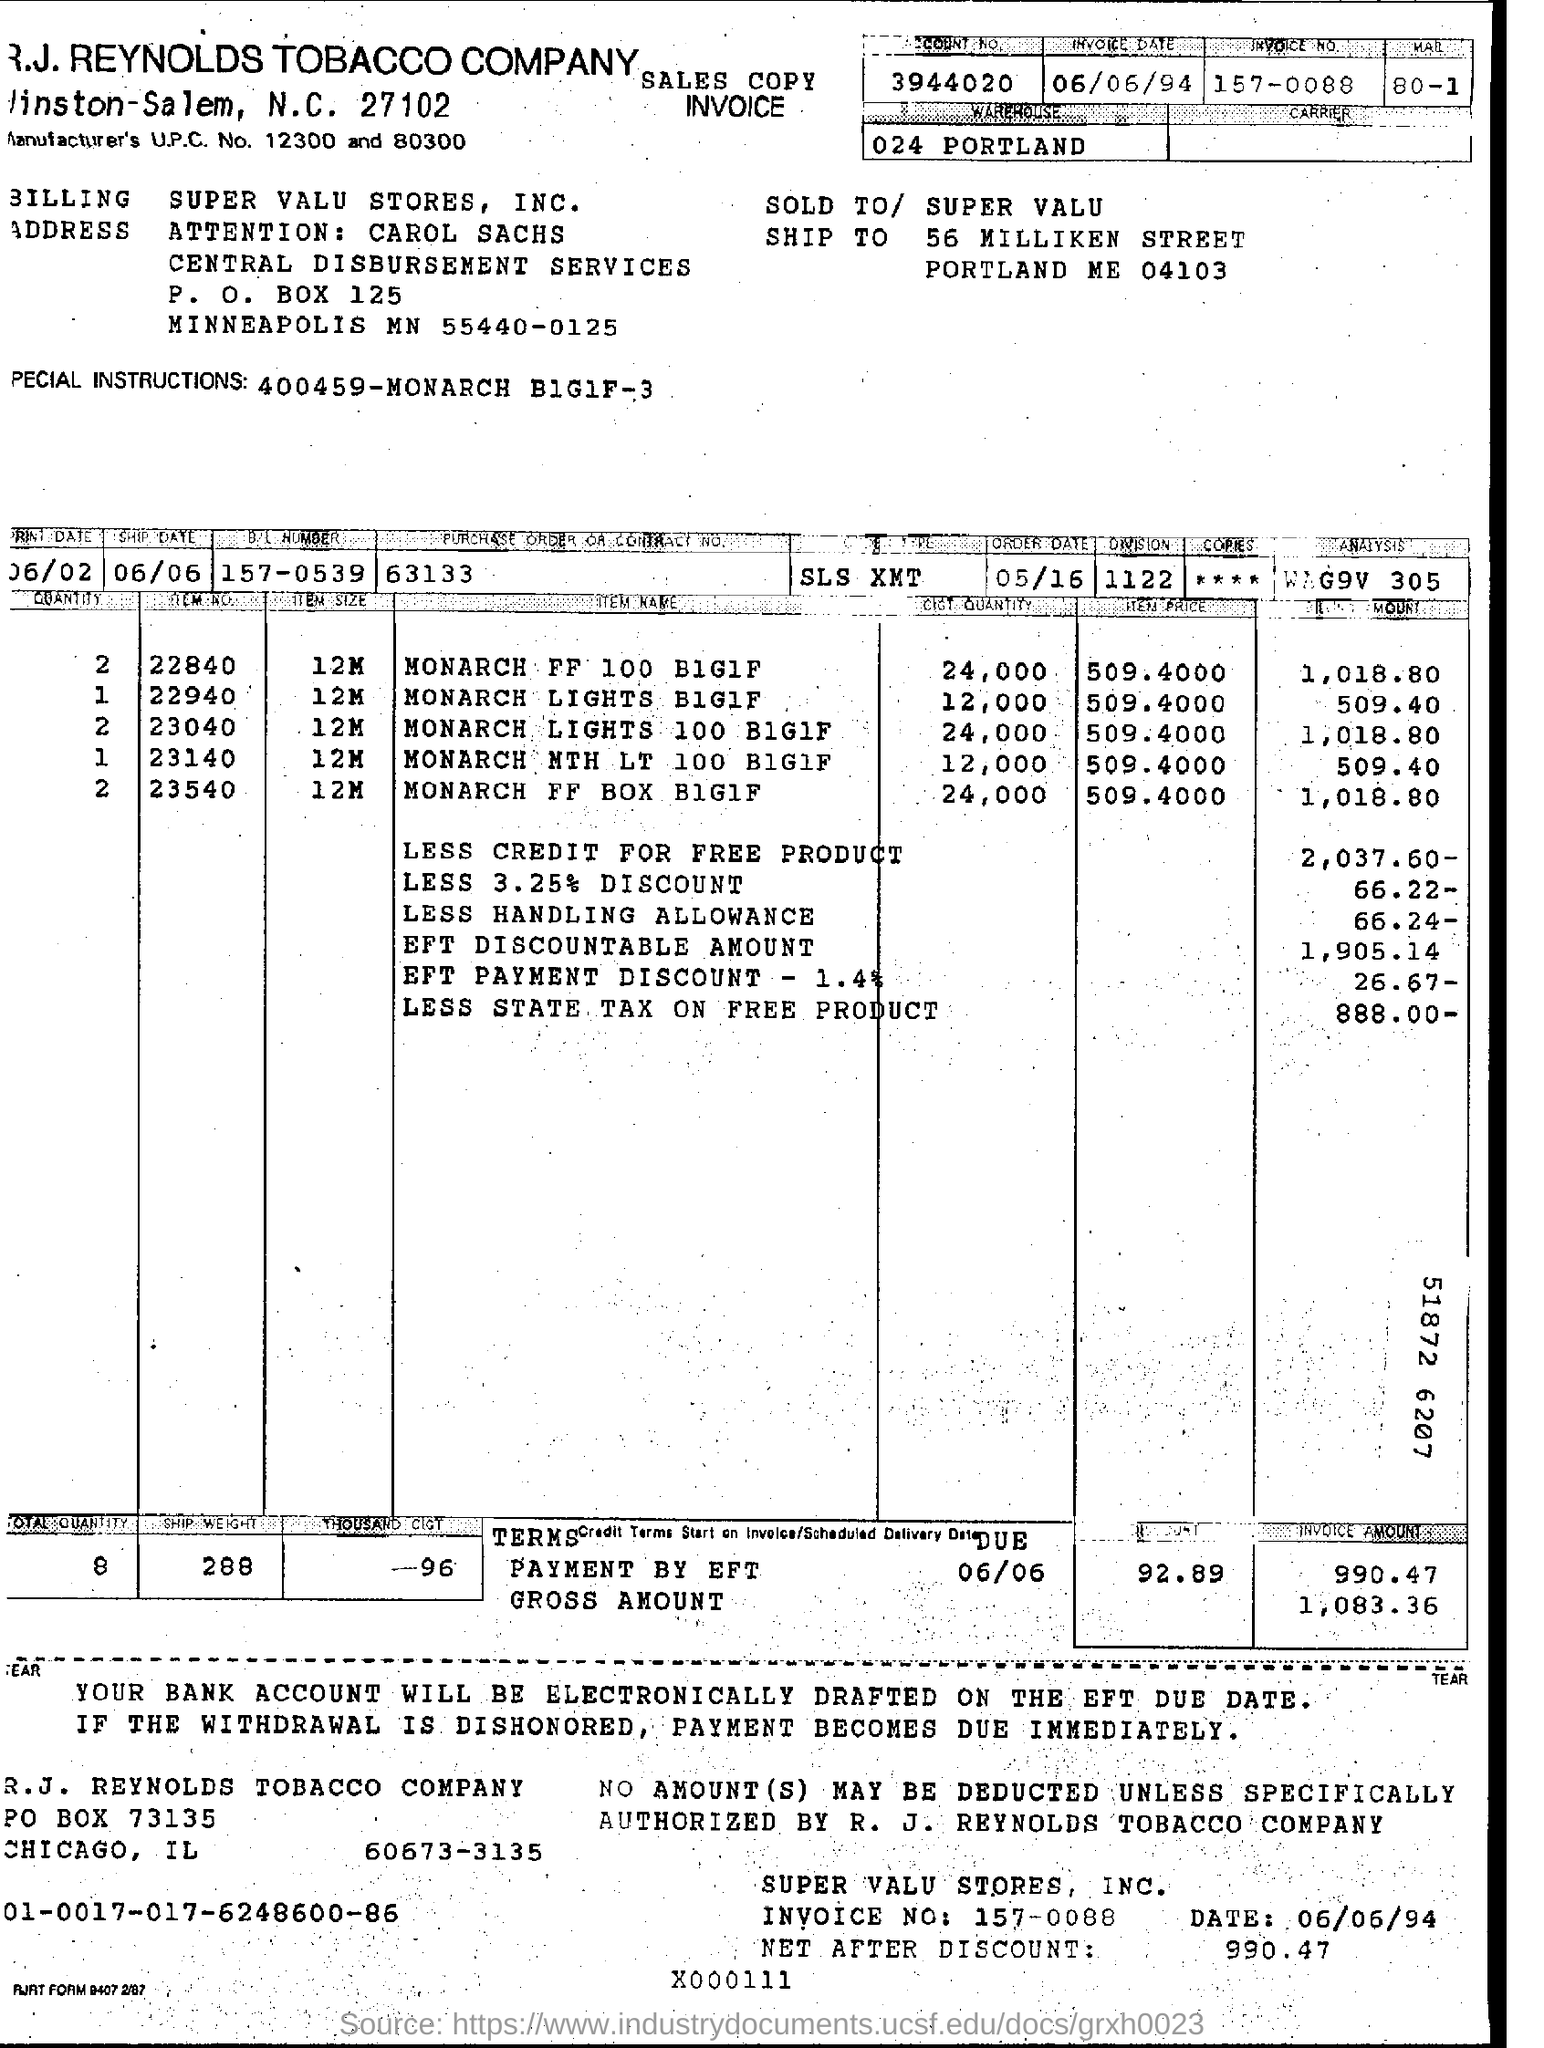Draw attention to some important aspects in this diagram. The item price of MONARCH FF 100 BIGIF is 509.4000. The Manufacturer's UPC numbers are 12300 and 80300. The invoice date is June 6th, 1994. 